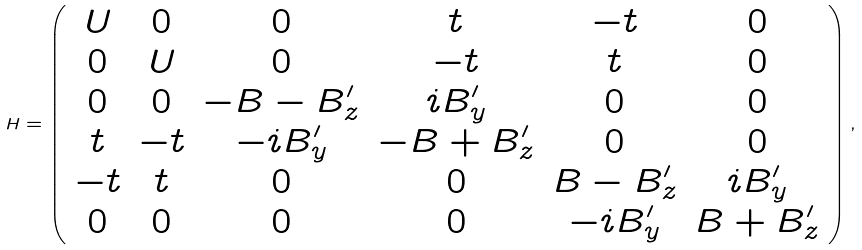<formula> <loc_0><loc_0><loc_500><loc_500>H = \left ( \begin{array} { c c c c c c } U & 0 & 0 & t & - t & 0 \\ 0 & U & 0 & - t & t & 0 \\ 0 & 0 & - B - B _ { z } ^ { \prime } & i B _ { y } ^ { \prime } & 0 & 0 \\ t & - t & - i B _ { y } ^ { \prime } & - B + B _ { z } ^ { \prime } & 0 & 0 \\ - t & t & 0 & 0 & B - B _ { z } ^ { \prime } & i B _ { y } ^ { \prime } \\ 0 & 0 & 0 & 0 & - i B _ { y } ^ { \prime } & B + B _ { z } ^ { \prime } \end{array} \right ) ,</formula> 